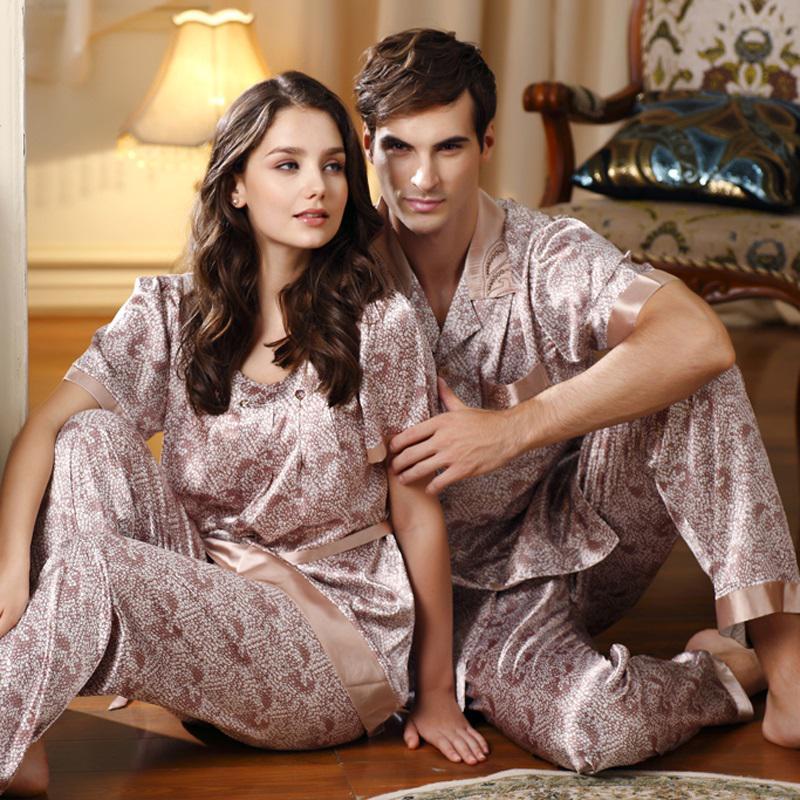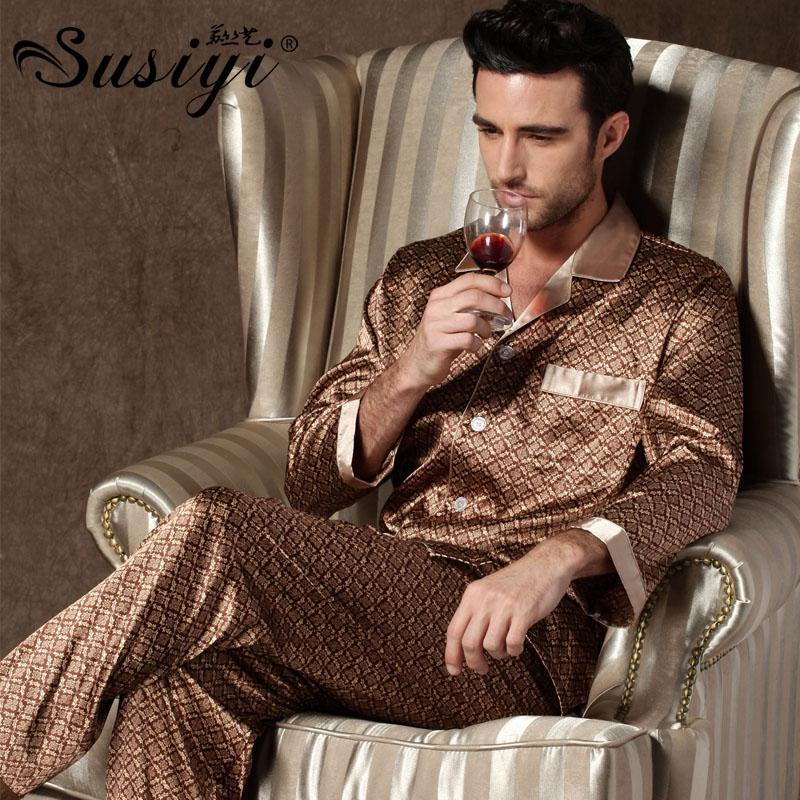The first image is the image on the left, the second image is the image on the right. Considering the images on both sides, is "the man is holding something in his hands in the right pic" valid? Answer yes or no. Yes. The first image is the image on the left, the second image is the image on the right. For the images shown, is this caption "In one of the images, a man is wearing checkered pajamas." true? Answer yes or no. No. 